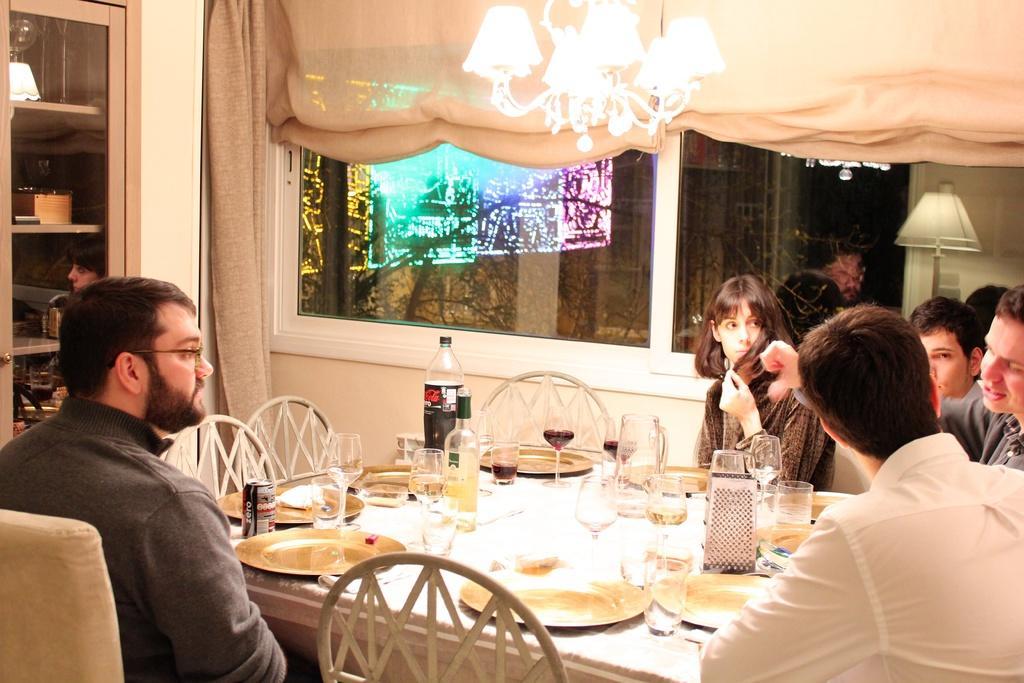How would you summarize this image in a sentence or two? In this image we can see few people are sitting on the chairs near the table. There are glasses, bottles, tins, plates placed on the table. This is the chandelier, curtains, glass window and lamp in the background. 